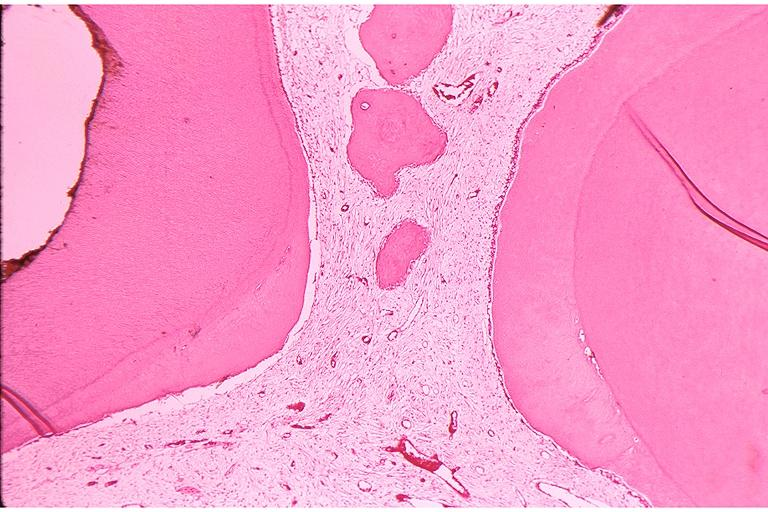does micrognathia triploid fetus show secondary dentin and pulp calcification?
Answer the question using a single word or phrase. No 